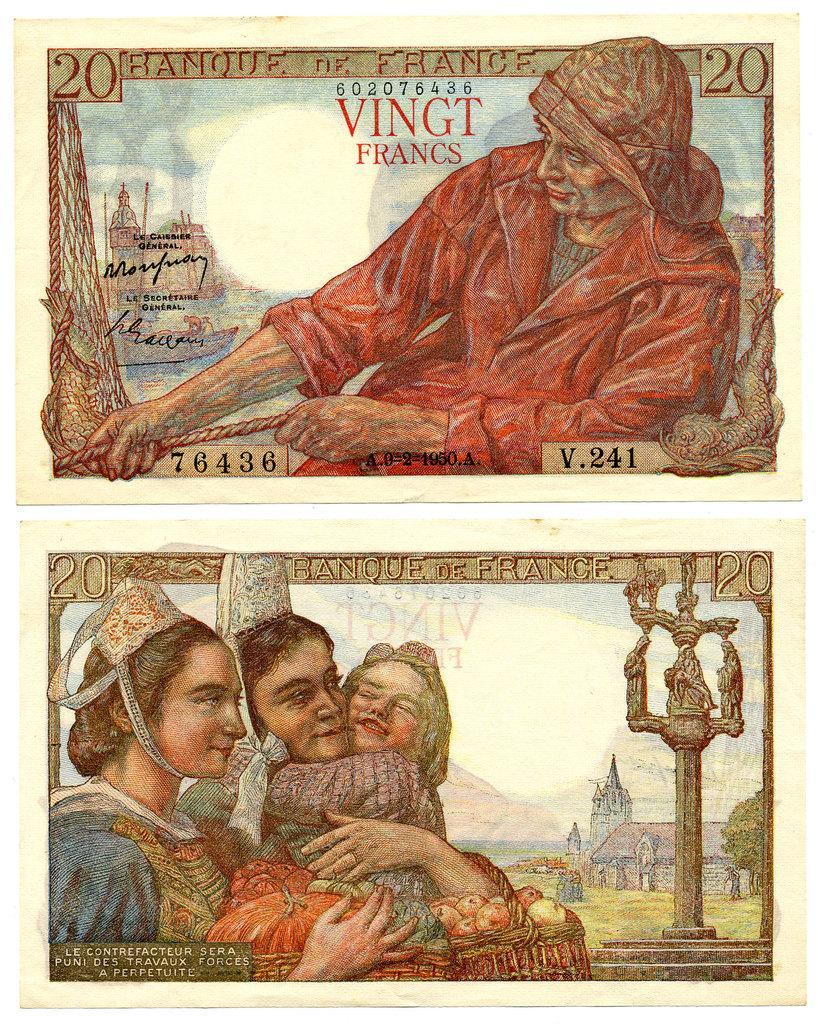In one or two sentences, can you explain what this image depicts? In this image we can see two currency notes with some images and text on it. 